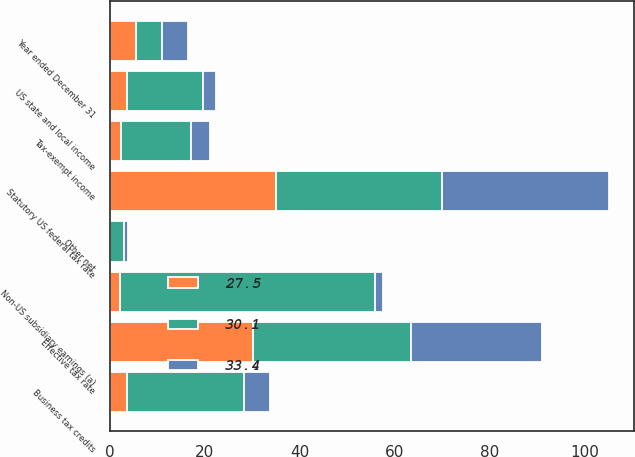<chart> <loc_0><loc_0><loc_500><loc_500><stacked_bar_chart><ecel><fcel>Year ended December 31<fcel>Statutory US federal tax rate<fcel>US state and local income<fcel>Tax-exempt income<fcel>Non-US subsidiary earnings (a)<fcel>Business tax credits<fcel>Other net<fcel>Effective tax rate<nl><fcel>27.5<fcel>5.5<fcel>35<fcel>3.6<fcel>2.4<fcel>2.2<fcel>3.7<fcel>0.2<fcel>30.1<nl><fcel>33.4<fcel>5.5<fcel>35<fcel>2.7<fcel>3.9<fcel>1.7<fcel>5.5<fcel>0.9<fcel>27.5<nl><fcel>30.1<fcel>5.5<fcel>35<fcel>16<fcel>14.8<fcel>53.6<fcel>24.5<fcel>2.8<fcel>33.4<nl></chart> 